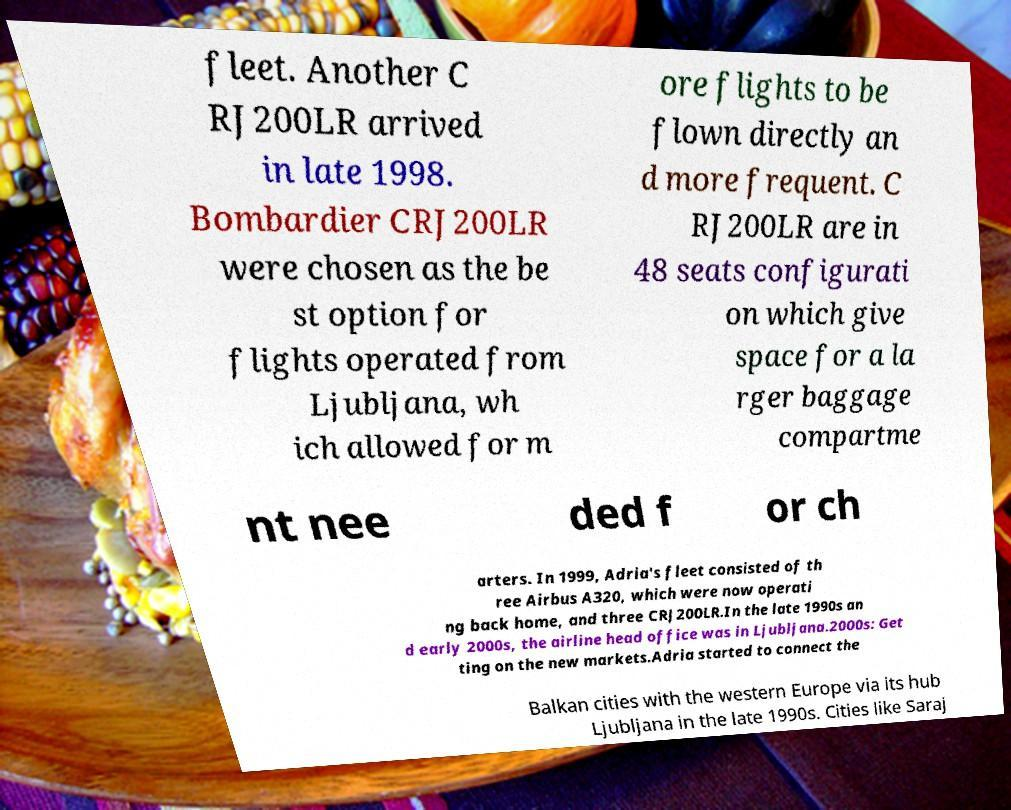Please read and relay the text visible in this image. What does it say? fleet. Another C RJ200LR arrived in late 1998. Bombardier CRJ200LR were chosen as the be st option for flights operated from Ljubljana, wh ich allowed for m ore flights to be flown directly an d more frequent. C RJ200LR are in 48 seats configurati on which give space for a la rger baggage compartme nt nee ded f or ch arters. In 1999, Adria's fleet consisted of th ree Airbus A320, which were now operati ng back home, and three CRJ200LR.In the late 1990s an d early 2000s, the airline head office was in Ljubljana.2000s: Get ting on the new markets.Adria started to connect the Balkan cities with the western Europe via its hub Ljubljana in the late 1990s. Cities like Saraj 